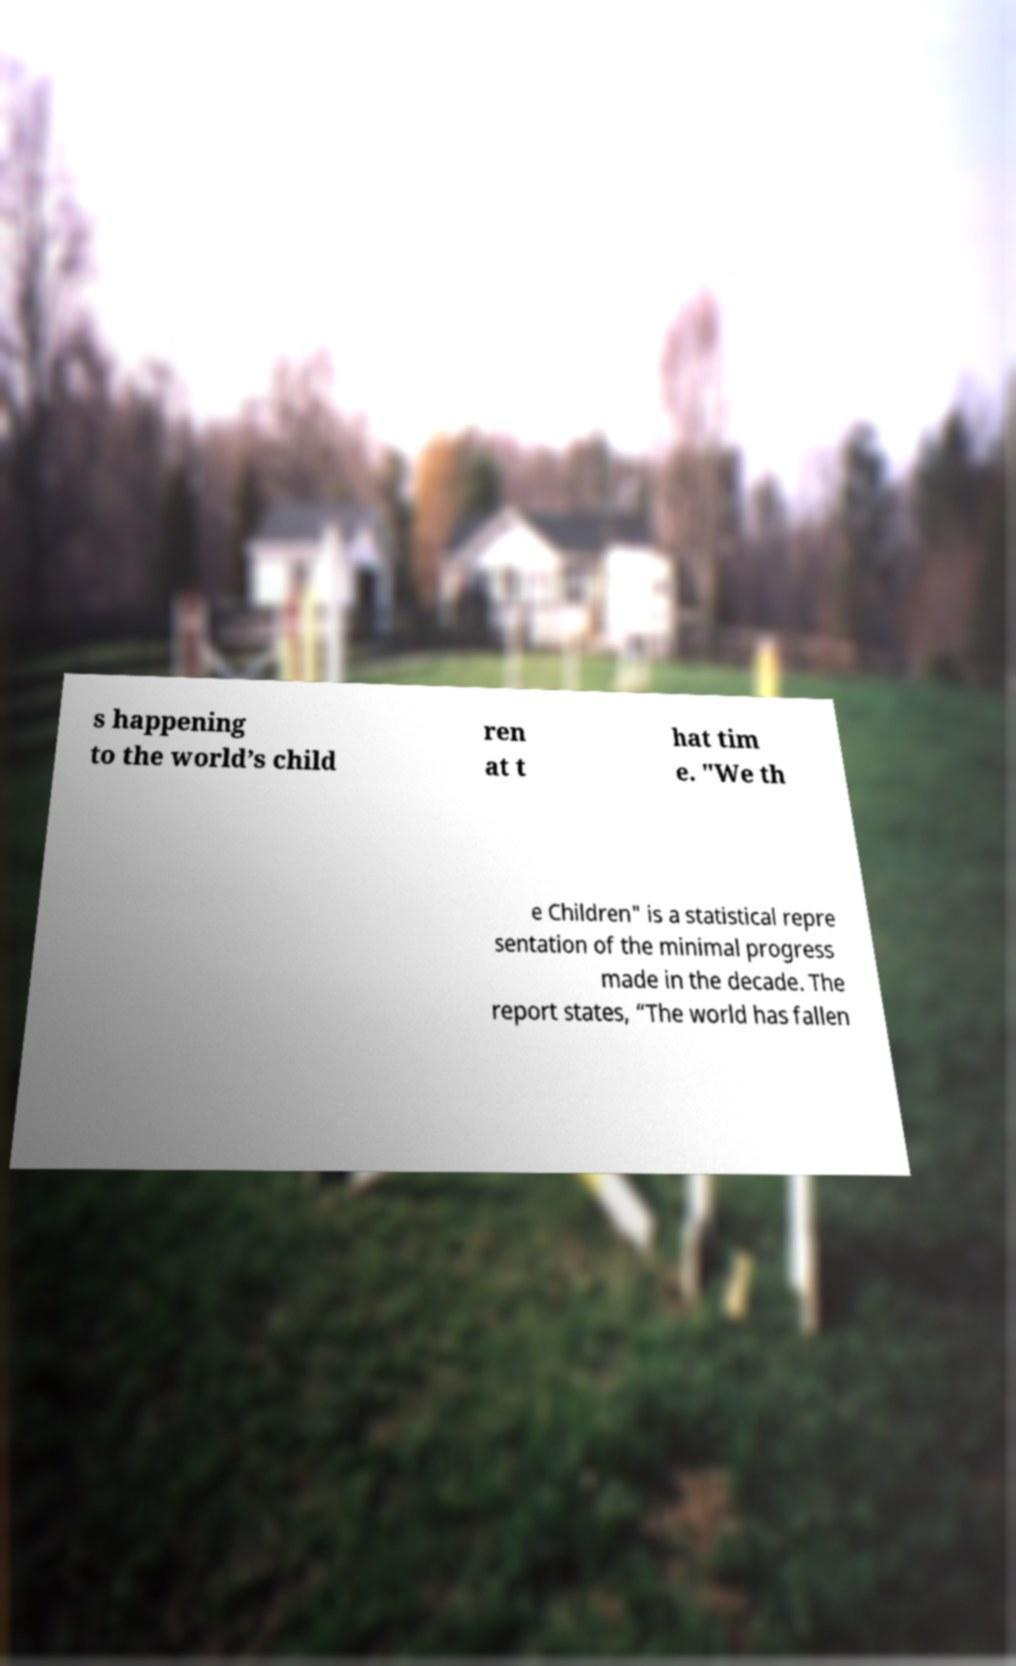Could you extract and type out the text from this image? s happening to the world’s child ren at t hat tim e. "We th e Children" is a statistical repre sentation of the minimal progress made in the decade. The report states, “The world has fallen 